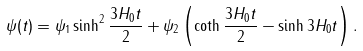Convert formula to latex. <formula><loc_0><loc_0><loc_500><loc_500>\psi ( t ) = \psi _ { 1 } \sinh ^ { 2 } \frac { 3 H _ { 0 } t } { 2 } + \psi _ { 2 } \left ( \coth \frac { 3 H _ { 0 } t } { 2 } - \sinh 3 H _ { 0 } t \right ) .</formula> 